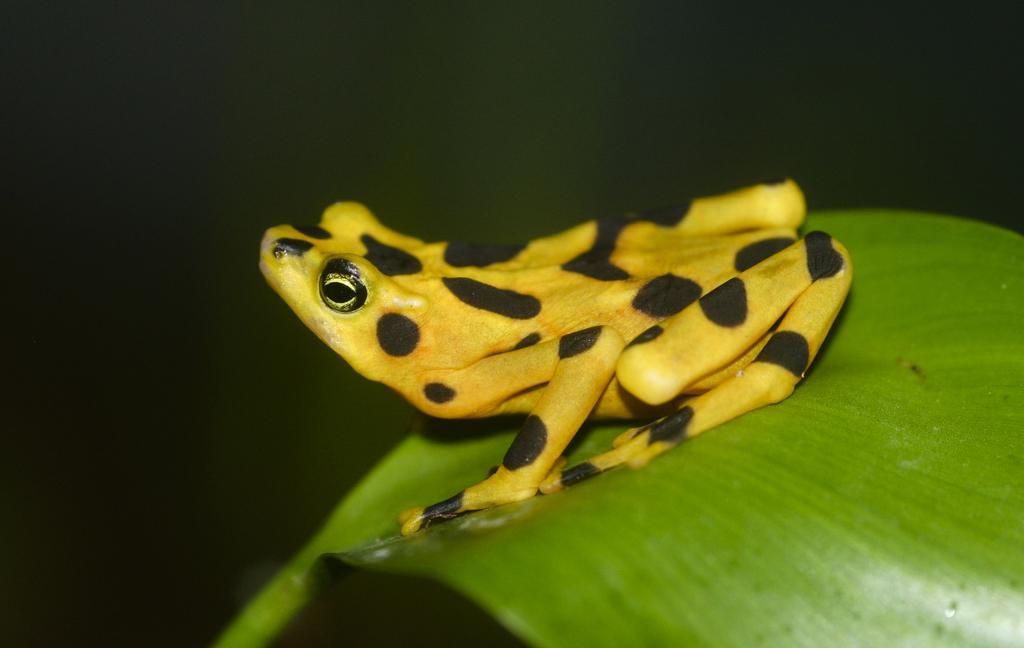How would you summarize this image in a sentence or two? In this image there is a frog on a leaf, in the background it is blurred. 